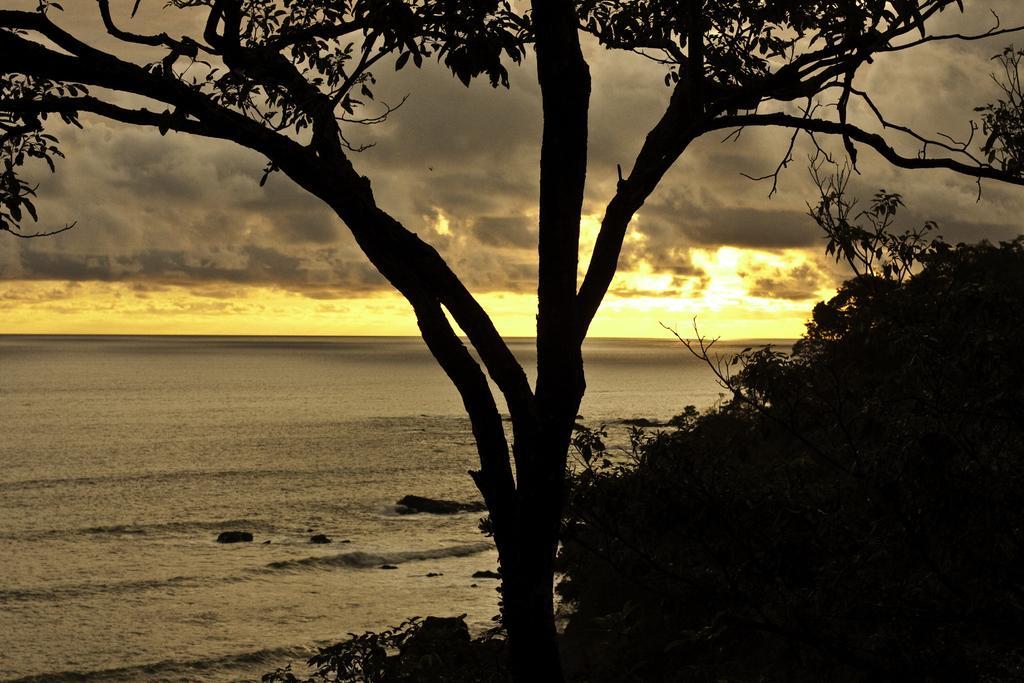Can you describe this image briefly? This image is taken outdoors. In the background there is the sky with clouds and sun. On the left side of the image there is a sea with water. In the middle of the image there is a tree with leaves, stems and branches. On the right side of the image there are a few plants. 